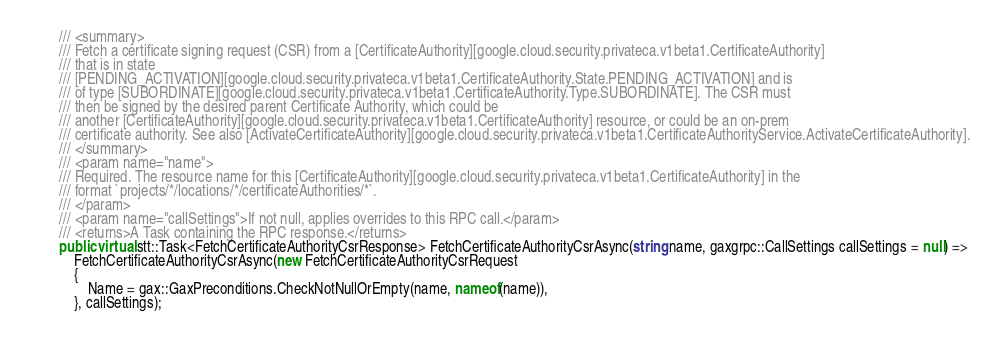Convert code to text. <code><loc_0><loc_0><loc_500><loc_500><_C#_>        /// <summary>
        /// Fetch a certificate signing request (CSR) from a [CertificateAuthority][google.cloud.security.privateca.v1beta1.CertificateAuthority]
        /// that is in state
        /// [PENDING_ACTIVATION][google.cloud.security.privateca.v1beta1.CertificateAuthority.State.PENDING_ACTIVATION] and is
        /// of type [SUBORDINATE][google.cloud.security.privateca.v1beta1.CertificateAuthority.Type.SUBORDINATE]. The CSR must
        /// then be signed by the desired parent Certificate Authority, which could be
        /// another [CertificateAuthority][google.cloud.security.privateca.v1beta1.CertificateAuthority] resource, or could be an on-prem
        /// certificate authority. See also [ActivateCertificateAuthority][google.cloud.security.privateca.v1beta1.CertificateAuthorityService.ActivateCertificateAuthority].
        /// </summary>
        /// <param name="name">
        /// Required. The resource name for this [CertificateAuthority][google.cloud.security.privateca.v1beta1.CertificateAuthority] in the
        /// format `projects/*/locations/*/certificateAuthorities/*`.
        /// </param>
        /// <param name="callSettings">If not null, applies overrides to this RPC call.</param>
        /// <returns>A Task containing the RPC response.</returns>
        public virtual stt::Task<FetchCertificateAuthorityCsrResponse> FetchCertificateAuthorityCsrAsync(string name, gaxgrpc::CallSettings callSettings = null) =>
            FetchCertificateAuthorityCsrAsync(new FetchCertificateAuthorityCsrRequest
            {
                Name = gax::GaxPreconditions.CheckNotNullOrEmpty(name, nameof(name)),
            }, callSettings);
</code> 